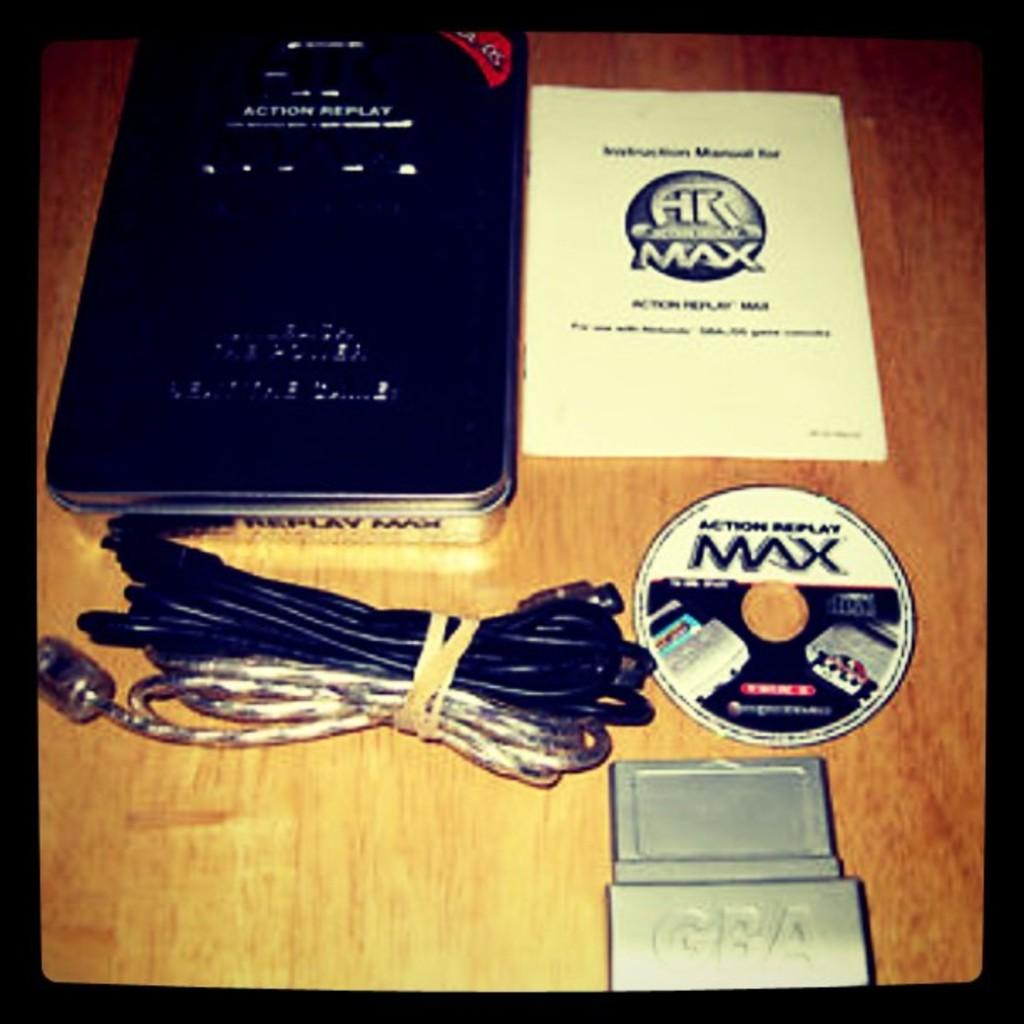<image>
Relay a brief, clear account of the picture shown. An Action Replay called HR Max and the stuff that came with it lay spread out on a wooden table. 